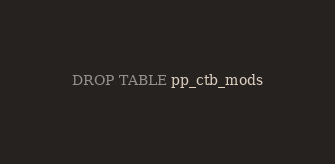Convert code to text. <code><loc_0><loc_0><loc_500><loc_500><_SQL_>DROP TABLE pp_ctb_mods</code> 